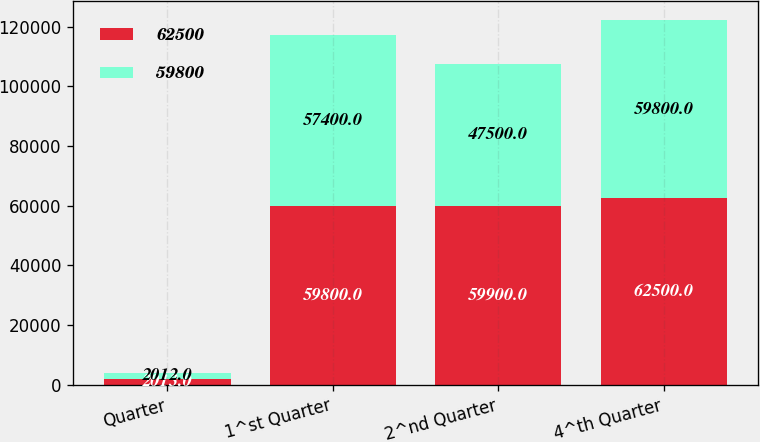Convert chart to OTSL. <chart><loc_0><loc_0><loc_500><loc_500><stacked_bar_chart><ecel><fcel>Quarter<fcel>1^st Quarter<fcel>2^nd Quarter<fcel>4^th Quarter<nl><fcel>62500<fcel>2013<fcel>59800<fcel>59900<fcel>62500<nl><fcel>59800<fcel>2012<fcel>57400<fcel>47500<fcel>59800<nl></chart> 